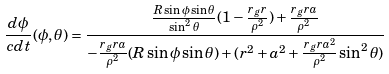Convert formula to latex. <formula><loc_0><loc_0><loc_500><loc_500>\frac { d \phi } { c d t } ( \phi , \theta ) = \frac { \frac { R \sin \phi \sin \theta } { \sin ^ { 2 } \theta } ( 1 - \frac { r _ { g } r } { \rho ^ { 2 } } ) + \frac { r _ { g } r a } { \rho ^ { 2 } } } { - \frac { r _ { g } r a } { \rho ^ { 2 } } ( R \sin \phi \sin \theta ) + ( r ^ { 2 } + a ^ { 2 } + \frac { r _ { g } r a ^ { 2 } } { \rho ^ { 2 } } \sin ^ { 2 } \theta ) }</formula> 